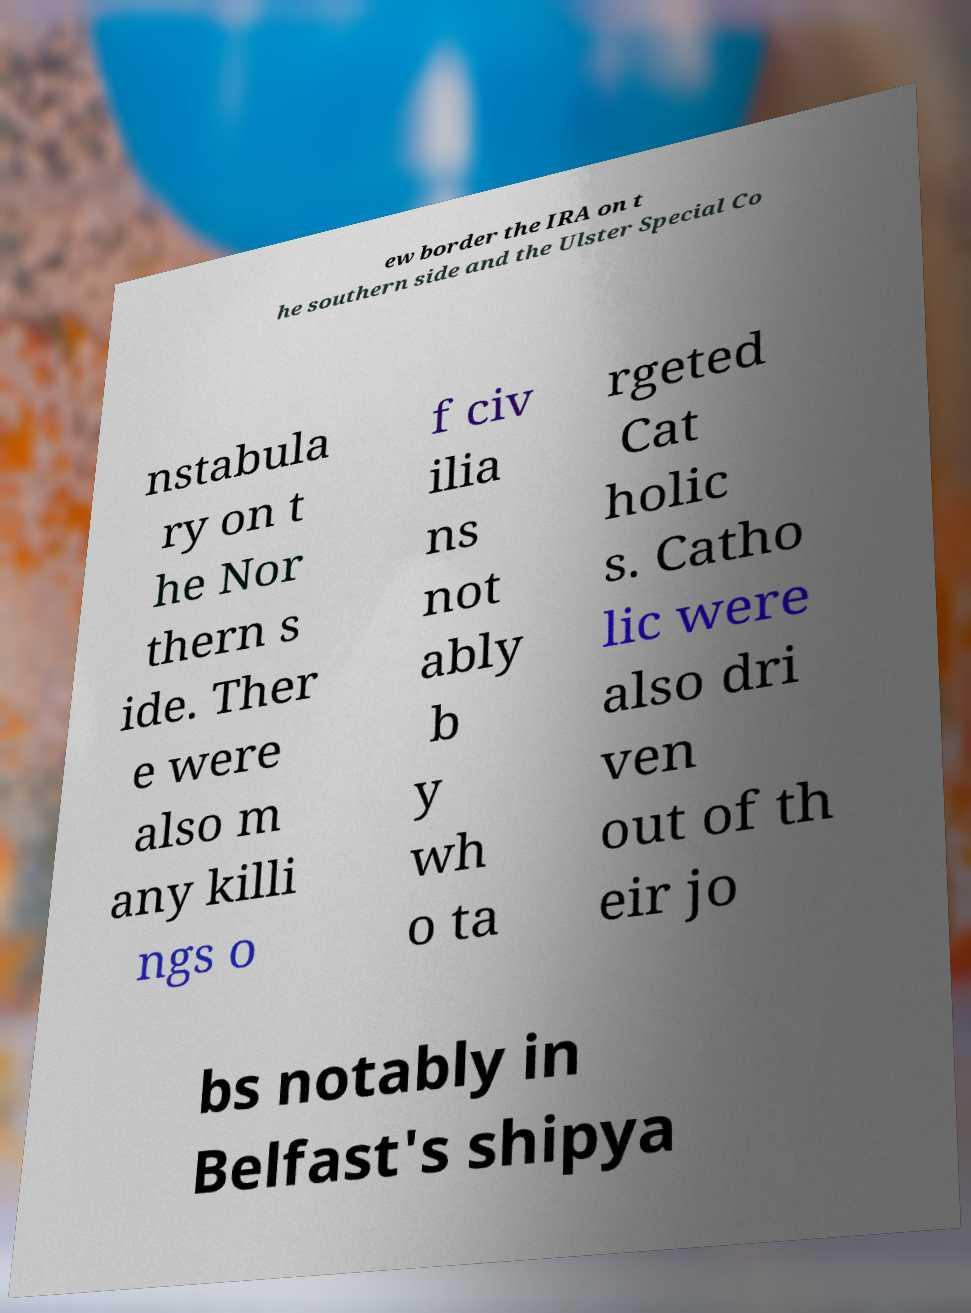What messages or text are displayed in this image? I need them in a readable, typed format. ew border the IRA on t he southern side and the Ulster Special Co nstabula ry on t he Nor thern s ide. Ther e were also m any killi ngs o f civ ilia ns not ably b y wh o ta rgeted Cat holic s. Catho lic were also dri ven out of th eir jo bs notably in Belfast's shipya 